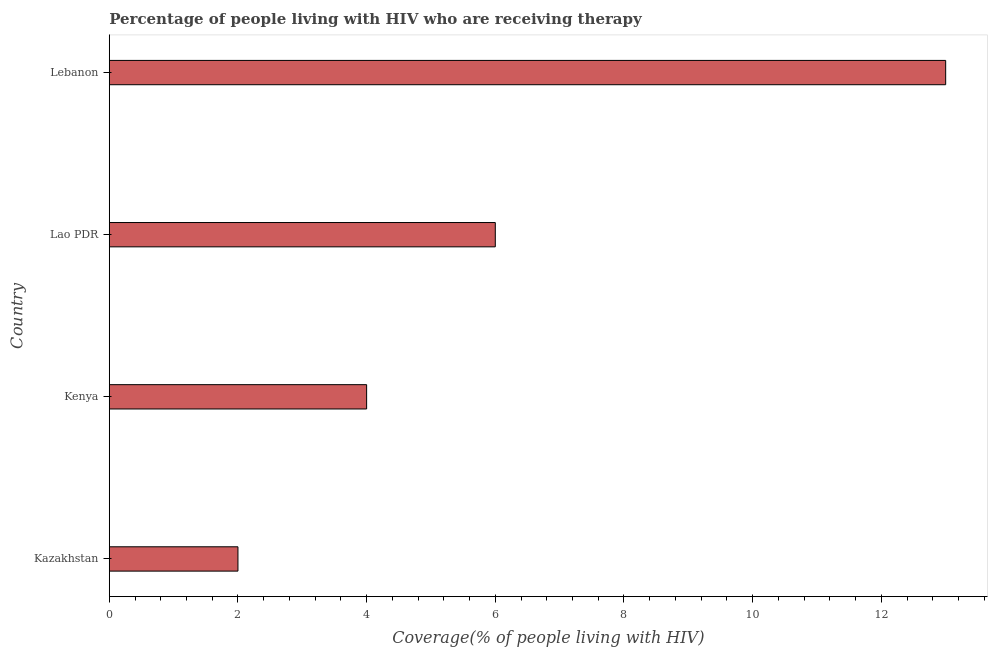Does the graph contain any zero values?
Make the answer very short. No. Does the graph contain grids?
Offer a terse response. No. What is the title of the graph?
Offer a terse response. Percentage of people living with HIV who are receiving therapy. What is the label or title of the X-axis?
Provide a short and direct response. Coverage(% of people living with HIV). What is the label or title of the Y-axis?
Keep it short and to the point. Country. What is the antiretroviral therapy coverage in Lebanon?
Provide a short and direct response. 13. Across all countries, what is the maximum antiretroviral therapy coverage?
Your response must be concise. 13. Across all countries, what is the minimum antiretroviral therapy coverage?
Your answer should be compact. 2. In which country was the antiretroviral therapy coverage maximum?
Give a very brief answer. Lebanon. In which country was the antiretroviral therapy coverage minimum?
Give a very brief answer. Kazakhstan. What is the sum of the antiretroviral therapy coverage?
Give a very brief answer. 25. What is the difference between the antiretroviral therapy coverage in Kazakhstan and Lebanon?
Make the answer very short. -11. What is the average antiretroviral therapy coverage per country?
Your response must be concise. 6.25. What is the ratio of the antiretroviral therapy coverage in Kazakhstan to that in Lao PDR?
Your answer should be compact. 0.33. What is the difference between the highest and the second highest antiretroviral therapy coverage?
Make the answer very short. 7. What is the difference between the highest and the lowest antiretroviral therapy coverage?
Give a very brief answer. 11. In how many countries, is the antiretroviral therapy coverage greater than the average antiretroviral therapy coverage taken over all countries?
Provide a succinct answer. 1. What is the difference between two consecutive major ticks on the X-axis?
Provide a succinct answer. 2. What is the Coverage(% of people living with HIV) of Kazakhstan?
Keep it short and to the point. 2. What is the Coverage(% of people living with HIV) in Kenya?
Your response must be concise. 4. What is the difference between the Coverage(% of people living with HIV) in Kazakhstan and Kenya?
Give a very brief answer. -2. What is the difference between the Coverage(% of people living with HIV) in Kazakhstan and Lao PDR?
Your response must be concise. -4. What is the difference between the Coverage(% of people living with HIV) in Kenya and Lebanon?
Offer a terse response. -9. What is the difference between the Coverage(% of people living with HIV) in Lao PDR and Lebanon?
Offer a very short reply. -7. What is the ratio of the Coverage(% of people living with HIV) in Kazakhstan to that in Lao PDR?
Make the answer very short. 0.33. What is the ratio of the Coverage(% of people living with HIV) in Kazakhstan to that in Lebanon?
Your response must be concise. 0.15. What is the ratio of the Coverage(% of people living with HIV) in Kenya to that in Lao PDR?
Your answer should be compact. 0.67. What is the ratio of the Coverage(% of people living with HIV) in Kenya to that in Lebanon?
Your answer should be very brief. 0.31. What is the ratio of the Coverage(% of people living with HIV) in Lao PDR to that in Lebanon?
Your answer should be very brief. 0.46. 